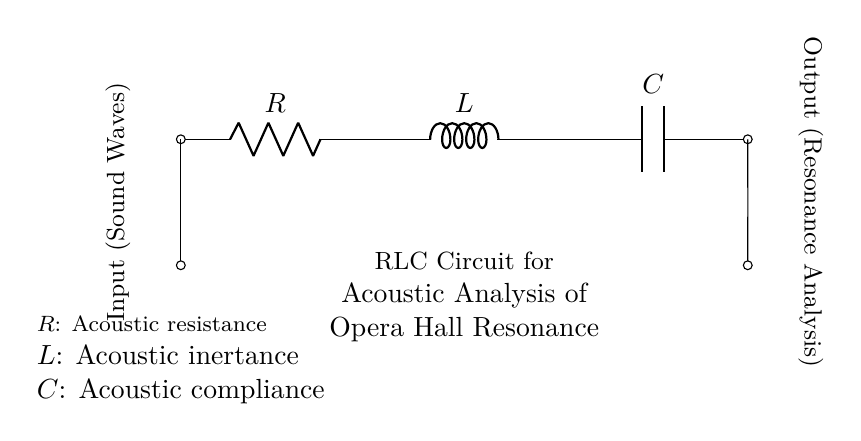What are the components present in the circuit? The circuit consists of a resistor, inductor, and capacitor, each labeled R, L, and C.
Answer: Resistor, Inductor, Capacitor What does the input represent in this circuit? The input labeled as "Input (Sound Waves)" signifies the entry point for the sound waves being analyzed for resonance.
Answer: Sound Waves What is the output of this circuit? The output is indicated as "Output (Resonance Analysis)," meaning the analysis results of the acoustic properties of the opera hall.
Answer: Resonance Analysis How are the components arranged in the circuit? The components are arranged in series: the resistor connects to the inductor, which connects to the capacitor, forming a continuous path for the signal.
Answer: Series Why is acoustic resistance represented by R? Acoustic resistance (R) is a measure of how much the circuit dissipates sound energy, analogous to electrical resistance in a circuit.
Answer: Energy dissipation What role does the inductor play in the acoustic circuit? The inductor (L) contributes to inertia, storing energy in a magnetic field, which affects the circuit's response to changes in the sound wave input.
Answer: Inertia storage How does compliance relate to the capacitor in this circuit? The capacitor (C) represents acoustic compliance, which is the ability of the medium to store energy in response to sound pressure, affecting the hall's resonance behavior.
Answer: Energy storage 